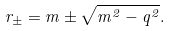Convert formula to latex. <formula><loc_0><loc_0><loc_500><loc_500>r _ { \pm } = m \pm \sqrt { m ^ { 2 } - q ^ { 2 } } .</formula> 